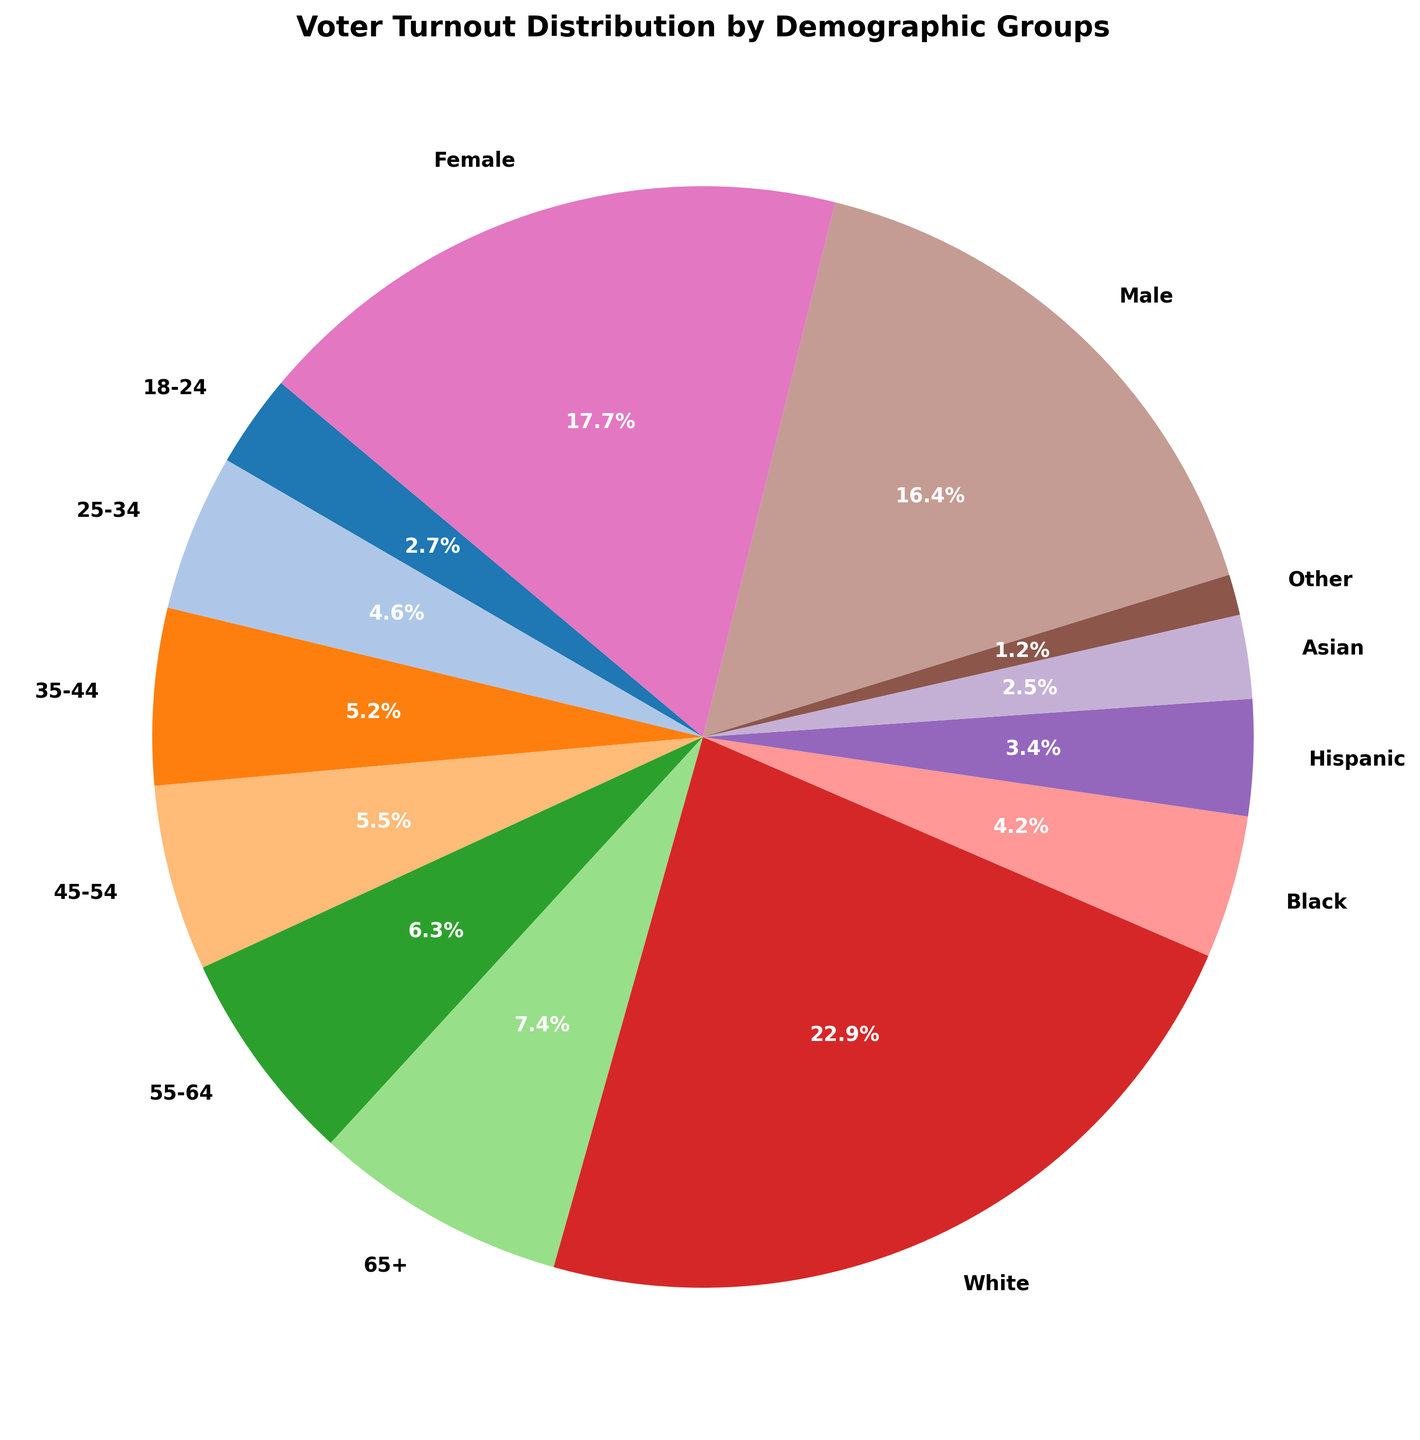What percentage of voter turnout is accounted for by the 65+ age group? The pie chart will show the percentage of voter turnout for each demographic group. Look for the segment labeled "65+" to find the percentage.
Answer: 21.8% Which demographic group had the highest voter turnout? By examining the pie chart, identify the segment with the largest percentage. This segment will be labeled with the corresponding demographic group.
Answer: 65+ What is the combined voter turnout percentage for Hispanic and Asian voters? Locate the percentage for Hispanic and Asian voters in the pie chart. Add these two percentages together: 10.0% + 7.2%.
Answer: 17.2% How does the voter turnout of females compare to males? Identify the segments labeled "Female" and "Male". Compare their percentages to determine which one is higher.
Answer: Female turnout is higher What is the difference in voter turnout between the White demographic group and the Black demographic group? Find the percentages for White and Black demographic groups in the pie chart. Subtract the smaller percentage (Black) from the larger percentage (White): 67.0% - 12.3%.
Answer: 54.7% Which demographic groups have a voter turnout percentage between 10% and 20%? Examine the pie chart for segments with percentages that fall between 10% and 20%. These should include: 25-34, 35-44, 45-54, Hispanic, and Black.
Answer: 25-34, 35-44, 45-54, Hispanic, Black Calculate the average voter turnout percentage for all age groups. Add the percentages of all age groups and divide by the number of age groups: (8.0% + 13.5% + 15.2% + 16.0% + 18.5% + 21.8%) / 6.
Answer: 15.5% What percentage of the total voter turnout is accounted for by non-White demographics? Sum the percentages for Black, Hispanic, Asian, and Other demographic groups: 12.3% + 10.0% + 7.2% + 3.5%.
Answer: 33.0% Which gender has higher voter turnout, and by what percentage? Compare the segments labeled "Male" and "Female". Subtract the smaller percentage (Male) from the larger percentage (Female): 52.0% - 48.0%.
Answer: Female by 4% Compare the voter turnout of the youngest age group (18-24) to the oldest age group (65+). Which has higher turnout and by what percentage? Identify the percentages for the 18-24 and 65+ age groups in the pie chart. Subtract the smaller percentage (18-24) from the larger percentage (65+): 21.8% - 8.0%.
Answer: 65+ by 13.8% 